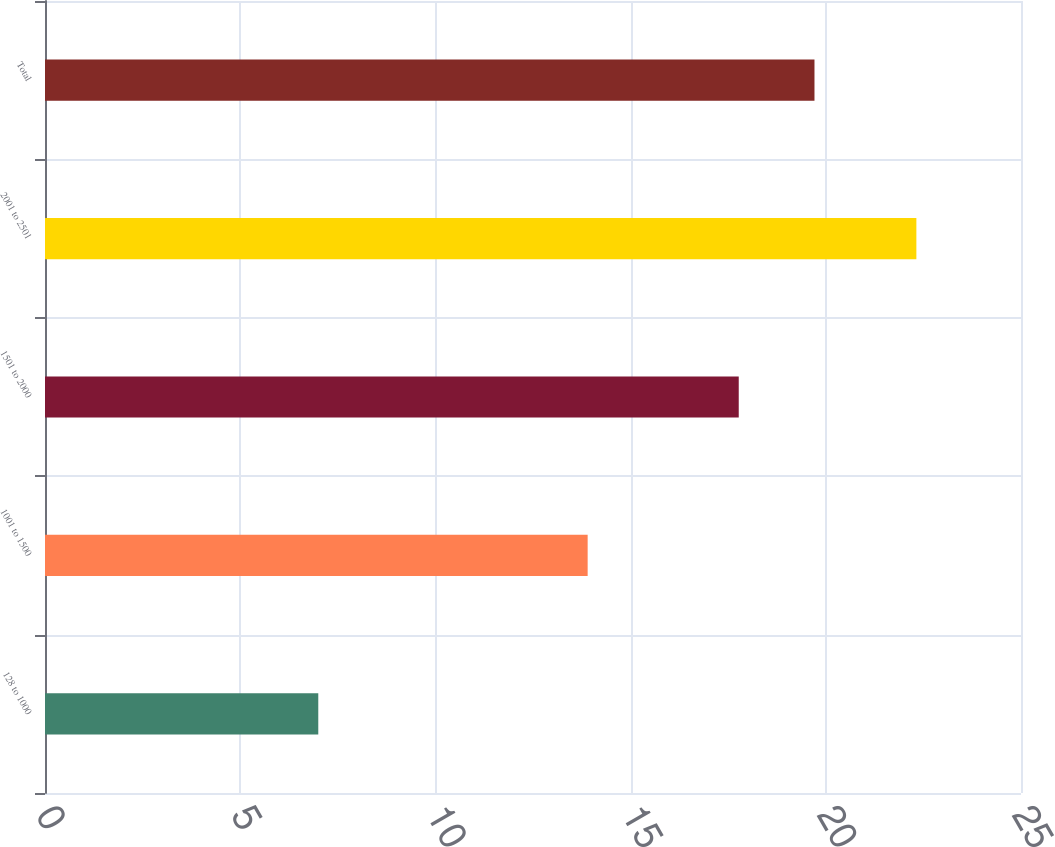Convert chart to OTSL. <chart><loc_0><loc_0><loc_500><loc_500><bar_chart><fcel>128 to 1000<fcel>1001 to 1500<fcel>1501 to 2000<fcel>2001 to 2501<fcel>Total<nl><fcel>7<fcel>13.9<fcel>17.77<fcel>22.32<fcel>19.71<nl></chart> 